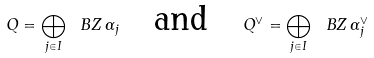Convert formula to latex. <formula><loc_0><loc_0><loc_500><loc_500>Q = \bigoplus _ { j \in I } \ B Z \, \alpha _ { j } \quad \text {and} \quad Q ^ { \vee } = \bigoplus _ { j \in I } \ B Z \, \alpha ^ { \vee } _ { j }</formula> 